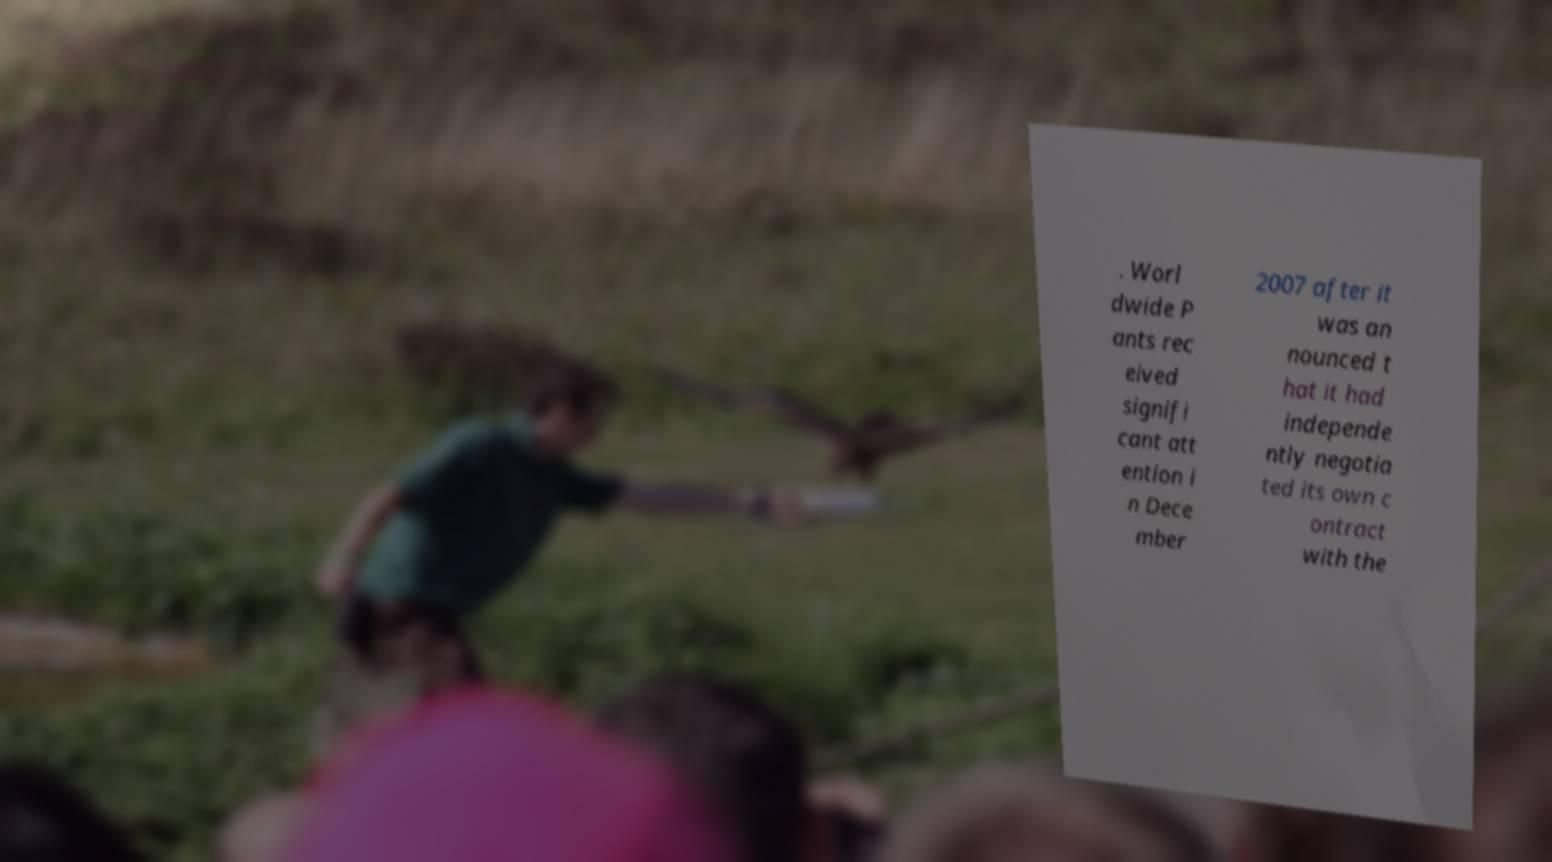Can you accurately transcribe the text from the provided image for me? . Worl dwide P ants rec eived signifi cant att ention i n Dece mber 2007 after it was an nounced t hat it had independe ntly negotia ted its own c ontract with the 